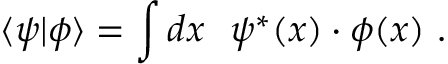Convert formula to latex. <formula><loc_0><loc_0><loc_500><loc_500>\langle \psi | \phi \rangle = \int d x \psi ^ { * } ( x ) \cdot \phi ( x ) .</formula> 